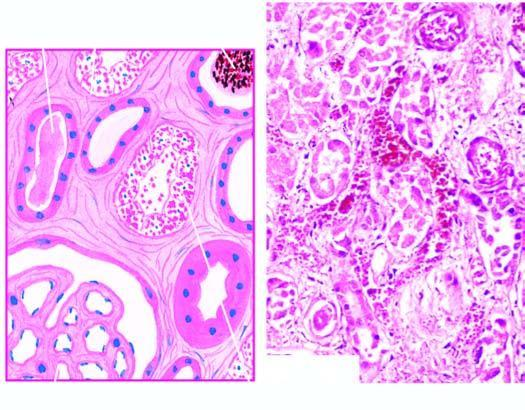s diagrammatic representation of pathologic changes in chronic hepatitis lined by regenerating thin and flat epithelium?
Answer the question using a single word or phrase. No 